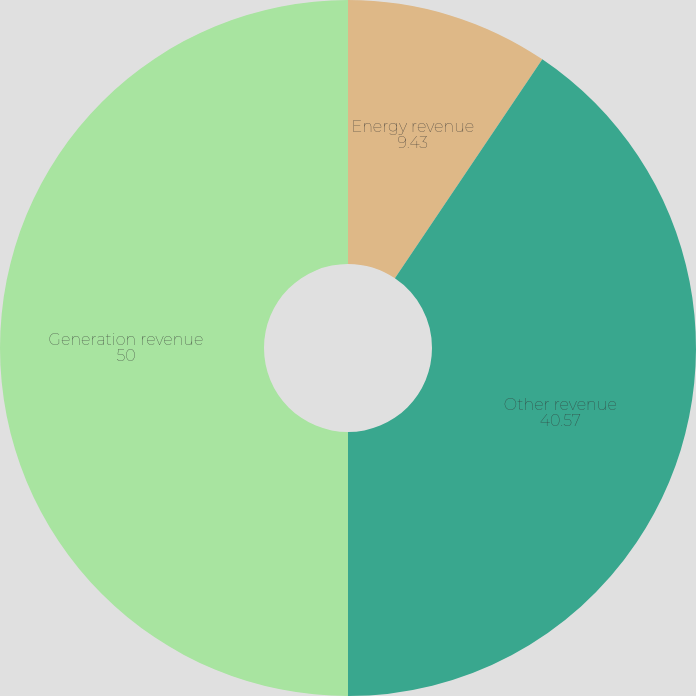Convert chart to OTSL. <chart><loc_0><loc_0><loc_500><loc_500><pie_chart><fcel>Energy revenue<fcel>Other revenue<fcel>Generation revenue<nl><fcel>9.43%<fcel>40.57%<fcel>50.0%<nl></chart> 